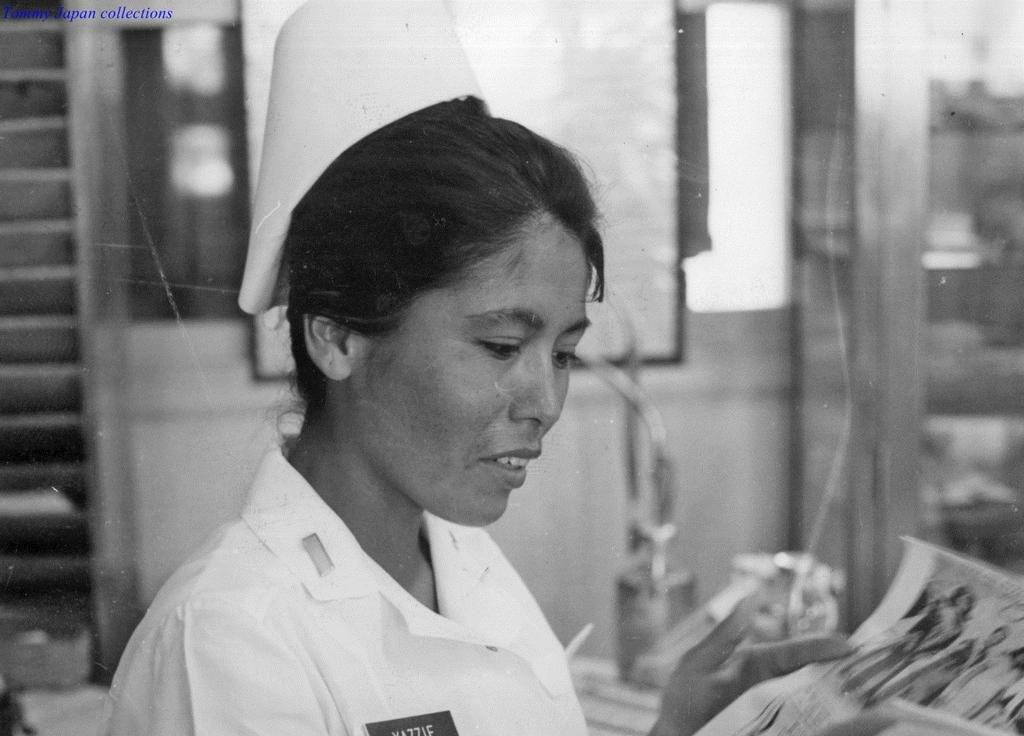What is the main subject of the image? There is a person in the image. What is the person wearing? The person is wearing a dress. What is the person holding in the image? The person is holding a paper. What can be seen in the background of the image? There are stairs and objects in the background of the image. What is the color scheme of the image? The image is black and white. What type of leather is visible on the edge of the paper in the image? There is no leather visible in the image, and the paper does not have an edge. 